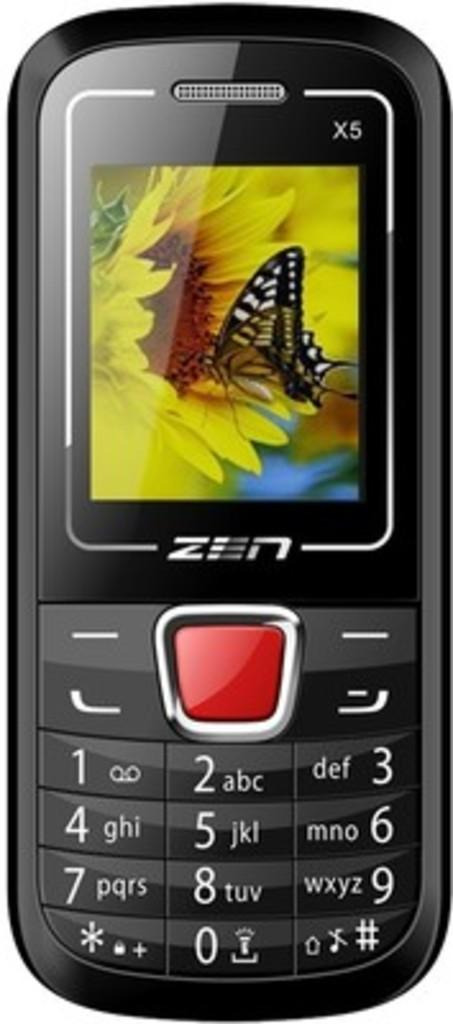Provide a one-sentence caption for the provided image. A ZEN branded cellphone with the background of a monarch butterfly on it. 